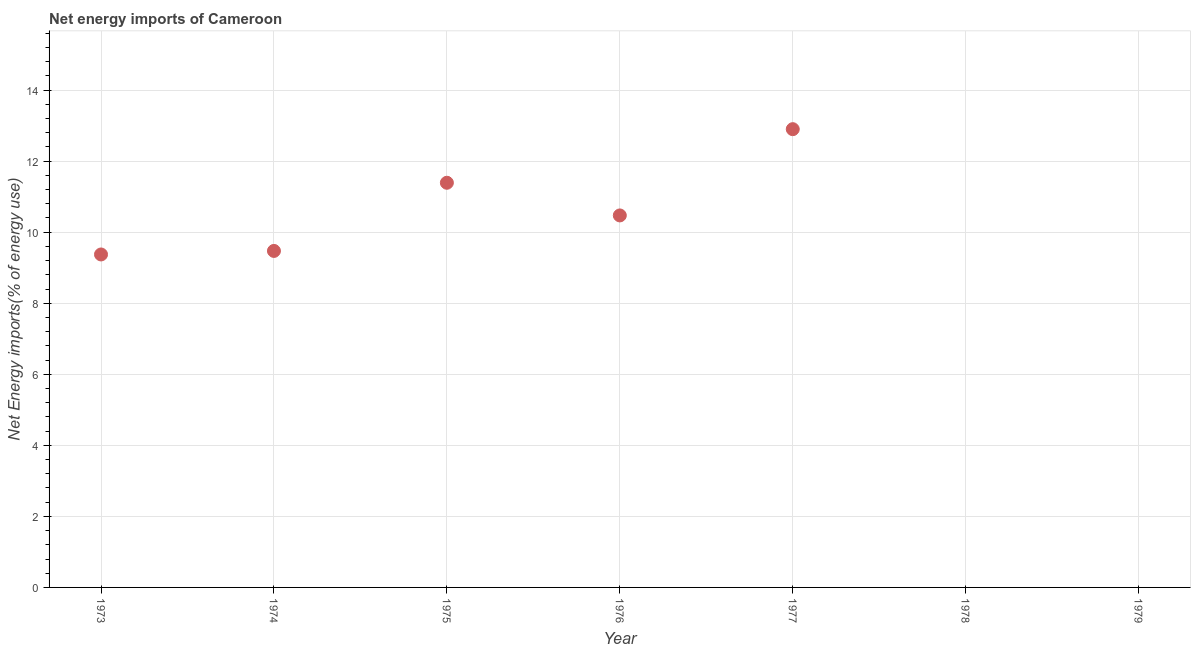What is the energy imports in 1975?
Your answer should be compact. 11.39. Across all years, what is the maximum energy imports?
Ensure brevity in your answer.  12.9. Across all years, what is the minimum energy imports?
Your answer should be compact. 0. In which year was the energy imports maximum?
Offer a very short reply. 1977. What is the sum of the energy imports?
Your response must be concise. 53.61. What is the difference between the energy imports in 1974 and 1977?
Your response must be concise. -3.43. What is the average energy imports per year?
Provide a succinct answer. 7.66. What is the median energy imports?
Provide a succinct answer. 9.47. What is the ratio of the energy imports in 1975 to that in 1977?
Your answer should be very brief. 0.88. Is the energy imports in 1976 less than that in 1977?
Provide a succinct answer. Yes. What is the difference between the highest and the second highest energy imports?
Your response must be concise. 1.51. Is the sum of the energy imports in 1974 and 1977 greater than the maximum energy imports across all years?
Make the answer very short. Yes. What is the difference between the highest and the lowest energy imports?
Make the answer very short. 12.9. In how many years, is the energy imports greater than the average energy imports taken over all years?
Ensure brevity in your answer.  5. Does the energy imports monotonically increase over the years?
Give a very brief answer. No. How many dotlines are there?
Your answer should be very brief. 1. How many years are there in the graph?
Your answer should be compact. 7. Does the graph contain any zero values?
Ensure brevity in your answer.  Yes. Does the graph contain grids?
Provide a short and direct response. Yes. What is the title of the graph?
Give a very brief answer. Net energy imports of Cameroon. What is the label or title of the Y-axis?
Give a very brief answer. Net Energy imports(% of energy use). What is the Net Energy imports(% of energy use) in 1973?
Your response must be concise. 9.37. What is the Net Energy imports(% of energy use) in 1974?
Offer a terse response. 9.47. What is the Net Energy imports(% of energy use) in 1975?
Your answer should be compact. 11.39. What is the Net Energy imports(% of energy use) in 1976?
Offer a terse response. 10.47. What is the Net Energy imports(% of energy use) in 1977?
Keep it short and to the point. 12.9. What is the Net Energy imports(% of energy use) in 1979?
Your answer should be very brief. 0. What is the difference between the Net Energy imports(% of energy use) in 1973 and 1974?
Keep it short and to the point. -0.1. What is the difference between the Net Energy imports(% of energy use) in 1973 and 1975?
Provide a succinct answer. -2.02. What is the difference between the Net Energy imports(% of energy use) in 1973 and 1976?
Give a very brief answer. -1.1. What is the difference between the Net Energy imports(% of energy use) in 1973 and 1977?
Ensure brevity in your answer.  -3.53. What is the difference between the Net Energy imports(% of energy use) in 1974 and 1975?
Make the answer very short. -1.92. What is the difference between the Net Energy imports(% of energy use) in 1974 and 1976?
Your answer should be very brief. -1. What is the difference between the Net Energy imports(% of energy use) in 1974 and 1977?
Your answer should be compact. -3.43. What is the difference between the Net Energy imports(% of energy use) in 1975 and 1976?
Ensure brevity in your answer.  0.92. What is the difference between the Net Energy imports(% of energy use) in 1975 and 1977?
Your answer should be very brief. -1.51. What is the difference between the Net Energy imports(% of energy use) in 1976 and 1977?
Give a very brief answer. -2.43. What is the ratio of the Net Energy imports(% of energy use) in 1973 to that in 1974?
Keep it short and to the point. 0.99. What is the ratio of the Net Energy imports(% of energy use) in 1973 to that in 1975?
Ensure brevity in your answer.  0.82. What is the ratio of the Net Energy imports(% of energy use) in 1973 to that in 1976?
Give a very brief answer. 0.9. What is the ratio of the Net Energy imports(% of energy use) in 1973 to that in 1977?
Make the answer very short. 0.73. What is the ratio of the Net Energy imports(% of energy use) in 1974 to that in 1975?
Your answer should be very brief. 0.83. What is the ratio of the Net Energy imports(% of energy use) in 1974 to that in 1976?
Give a very brief answer. 0.91. What is the ratio of the Net Energy imports(% of energy use) in 1974 to that in 1977?
Offer a very short reply. 0.73. What is the ratio of the Net Energy imports(% of energy use) in 1975 to that in 1976?
Ensure brevity in your answer.  1.09. What is the ratio of the Net Energy imports(% of energy use) in 1975 to that in 1977?
Your response must be concise. 0.88. What is the ratio of the Net Energy imports(% of energy use) in 1976 to that in 1977?
Your answer should be very brief. 0.81. 